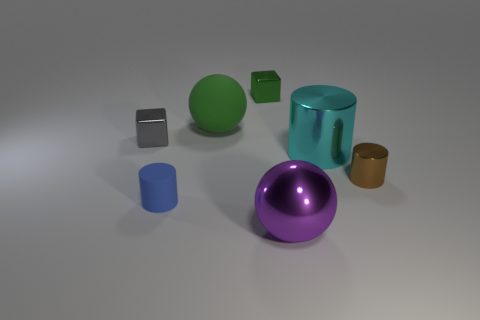Subtract all small blue rubber cylinders. How many cylinders are left? 2 Subtract all gray cubes. How many cubes are left? 1 Add 1 tiny matte objects. How many objects exist? 8 Subtract all balls. How many objects are left? 5 Subtract 0 gray cylinders. How many objects are left? 7 Subtract all cyan spheres. Subtract all cyan cubes. How many spheres are left? 2 Subtract all blue rubber objects. Subtract all metallic balls. How many objects are left? 5 Add 2 small cubes. How many small cubes are left? 4 Add 2 tiny brown blocks. How many tiny brown blocks exist? 2 